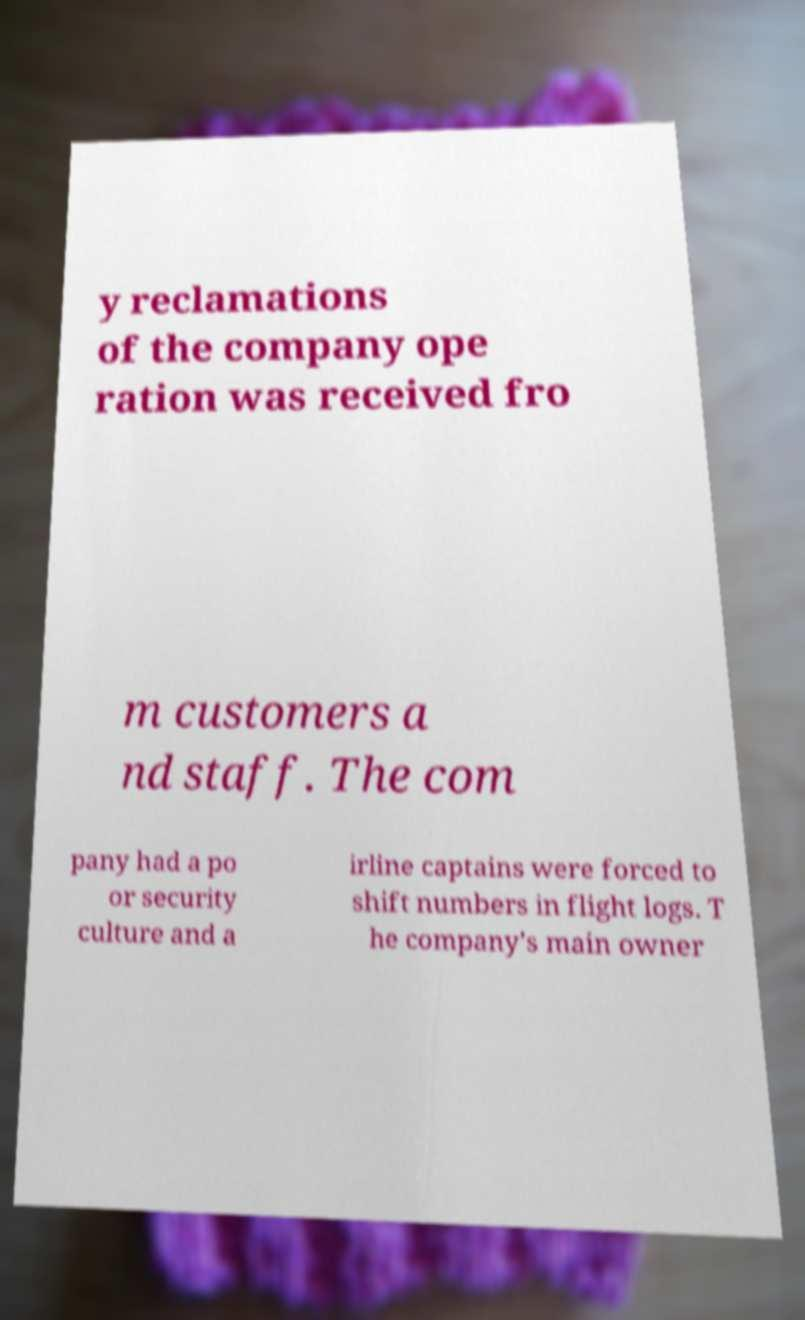For documentation purposes, I need the text within this image transcribed. Could you provide that? y reclamations of the company ope ration was received fro m customers a nd staff. The com pany had a po or security culture and a irline captains were forced to shift numbers in flight logs. T he company's main owner 